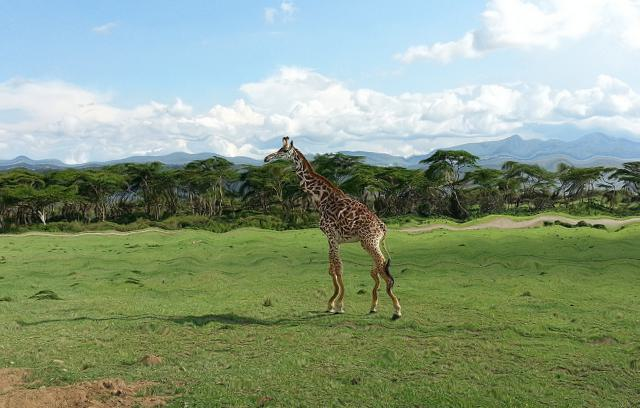What can you infer about the giraffe's diet from the picture? Giraffes are herbivores, primarily feeding on leaves, fruits, and flowers. The presence of acacia trees in the image suggests that the giraffe has access to its preferred food source, as these trees are known for their nutrient-rich leaves, which are a staple in a giraffe's diet. 